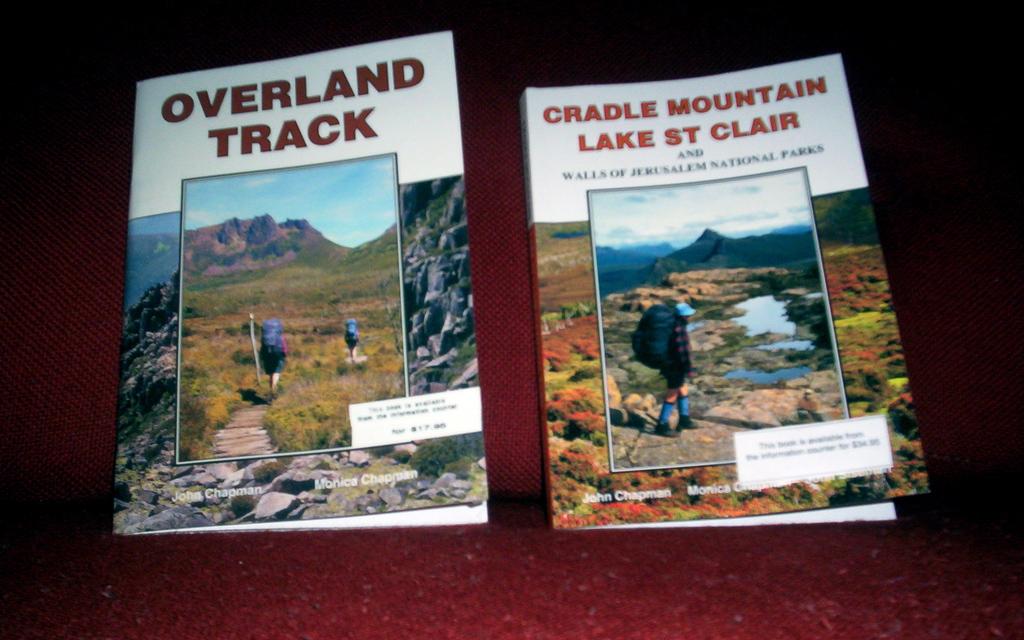What is the male author of both books shown?
Provide a short and direct response. John chapman. 